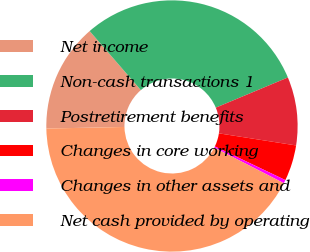Convert chart. <chart><loc_0><loc_0><loc_500><loc_500><pie_chart><fcel>Net income<fcel>Non-cash transactions 1<fcel>Postretirement benefits<fcel>Changes in core working<fcel>Changes in other assets and<fcel>Net cash provided by operating<nl><fcel>13.95%<fcel>30.06%<fcel>8.78%<fcel>4.61%<fcel>0.44%<fcel>42.15%<nl></chart> 